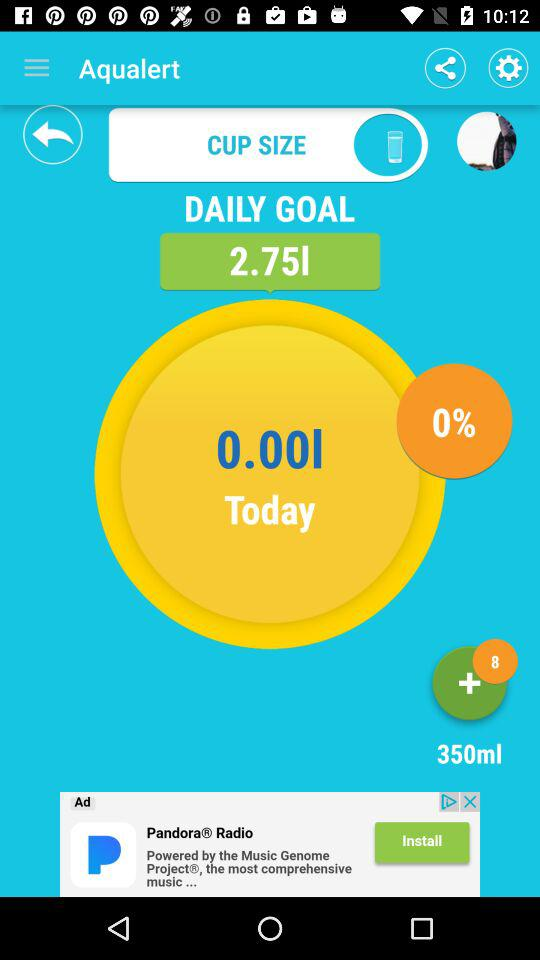How many liters of liquid do we consume for a daily goal? We can consume 2.75 liters of liquid for a daily goal. 